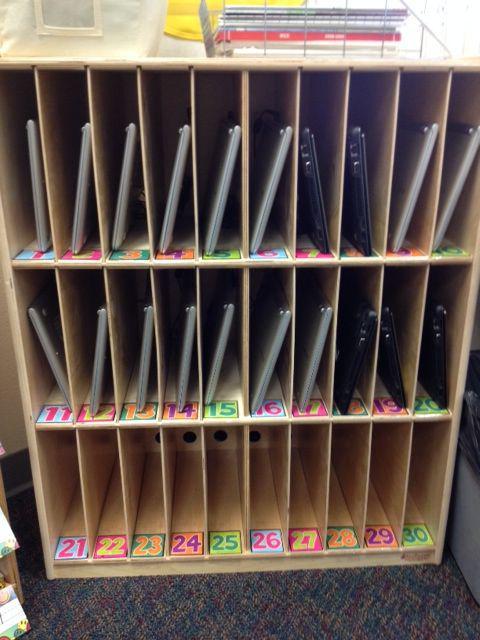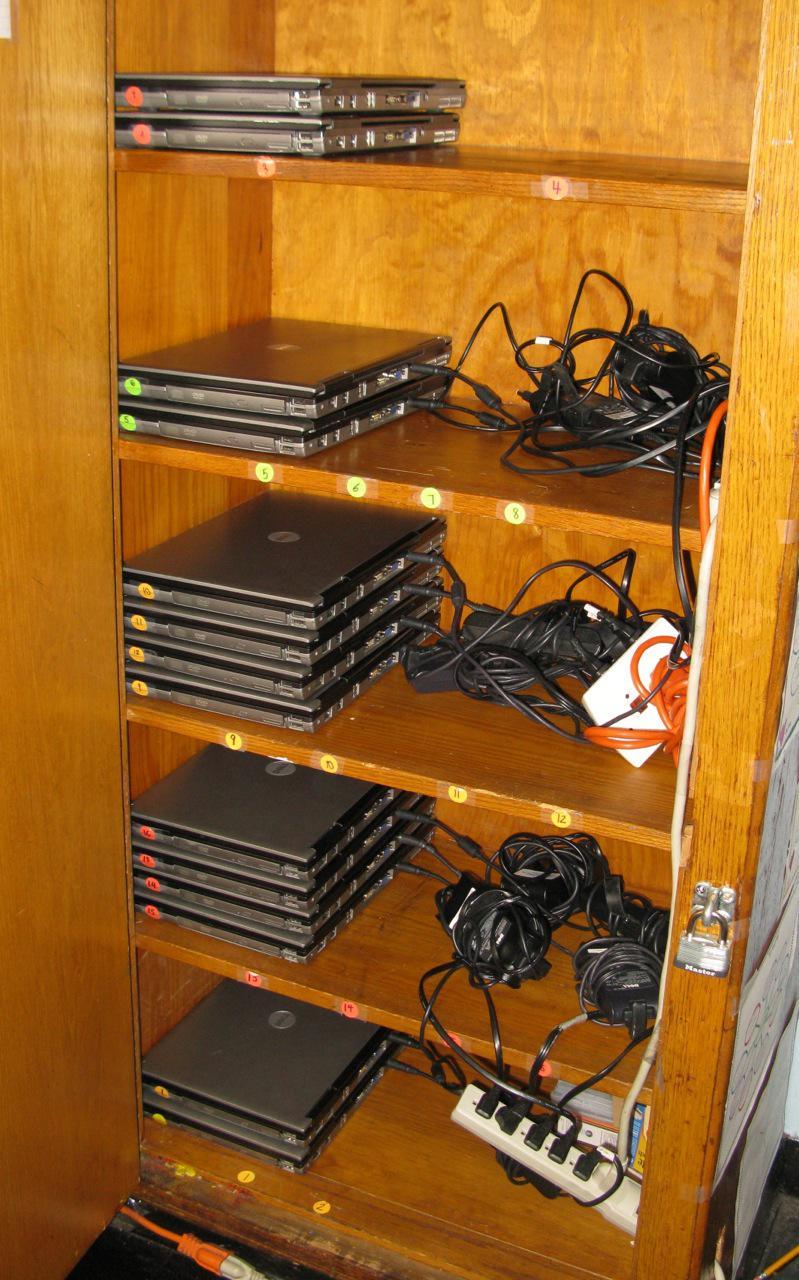The first image is the image on the left, the second image is the image on the right. Evaluate the accuracy of this statement regarding the images: "All of the computers are sitting flat.". Is it true? Answer yes or no. No. 